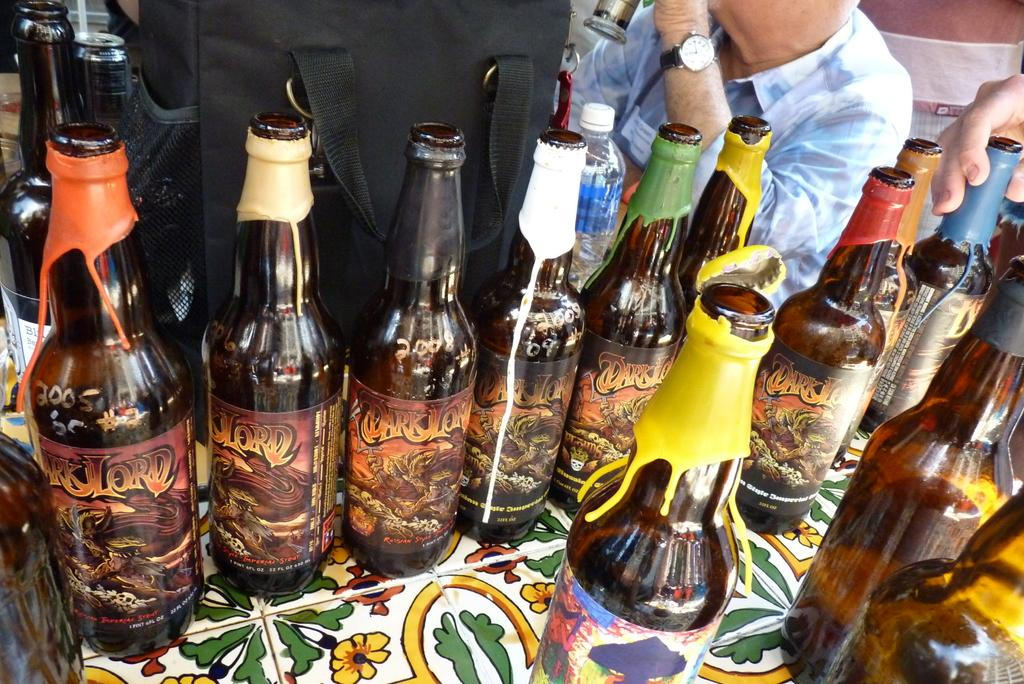<image>
Share a concise interpretation of the image provided. Alcohol bottles lined up on the table with Dark Lord written on them. 